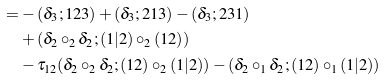<formula> <loc_0><loc_0><loc_500><loc_500>= & - ( \delta _ { 3 } ; 1 2 3 ) + ( \delta _ { 3 } ; 2 1 3 ) - ( \delta _ { 3 } ; 2 3 1 ) \\ & + ( \delta _ { 2 } \circ _ { 2 } \delta _ { 2 } ; ( 1 | 2 ) \circ _ { 2 } ( 1 2 ) ) \\ & - \tau _ { 1 2 } ( \delta _ { 2 } \circ _ { 2 } \delta _ { 2 } ; ( 1 2 ) \circ _ { 2 } ( 1 | 2 ) ) - ( \delta _ { 2 } \circ _ { 1 } \delta _ { 2 } ; ( 1 2 ) \circ _ { 1 } ( 1 | 2 ) )</formula> 